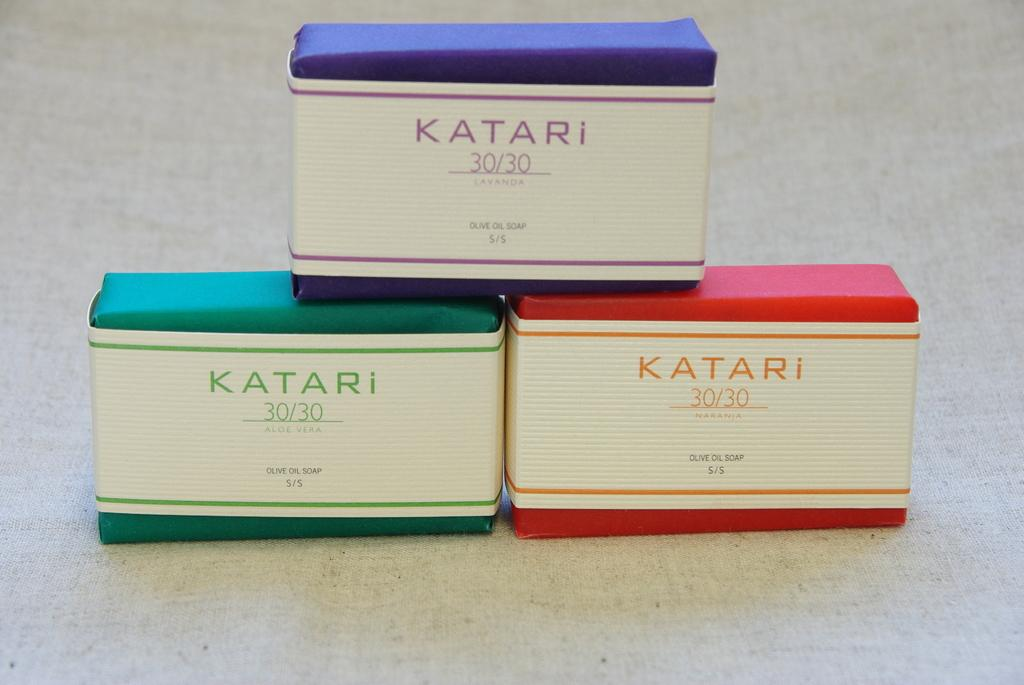<image>
Provide a brief description of the given image. A product named Katari has a 30/30 concentration. 